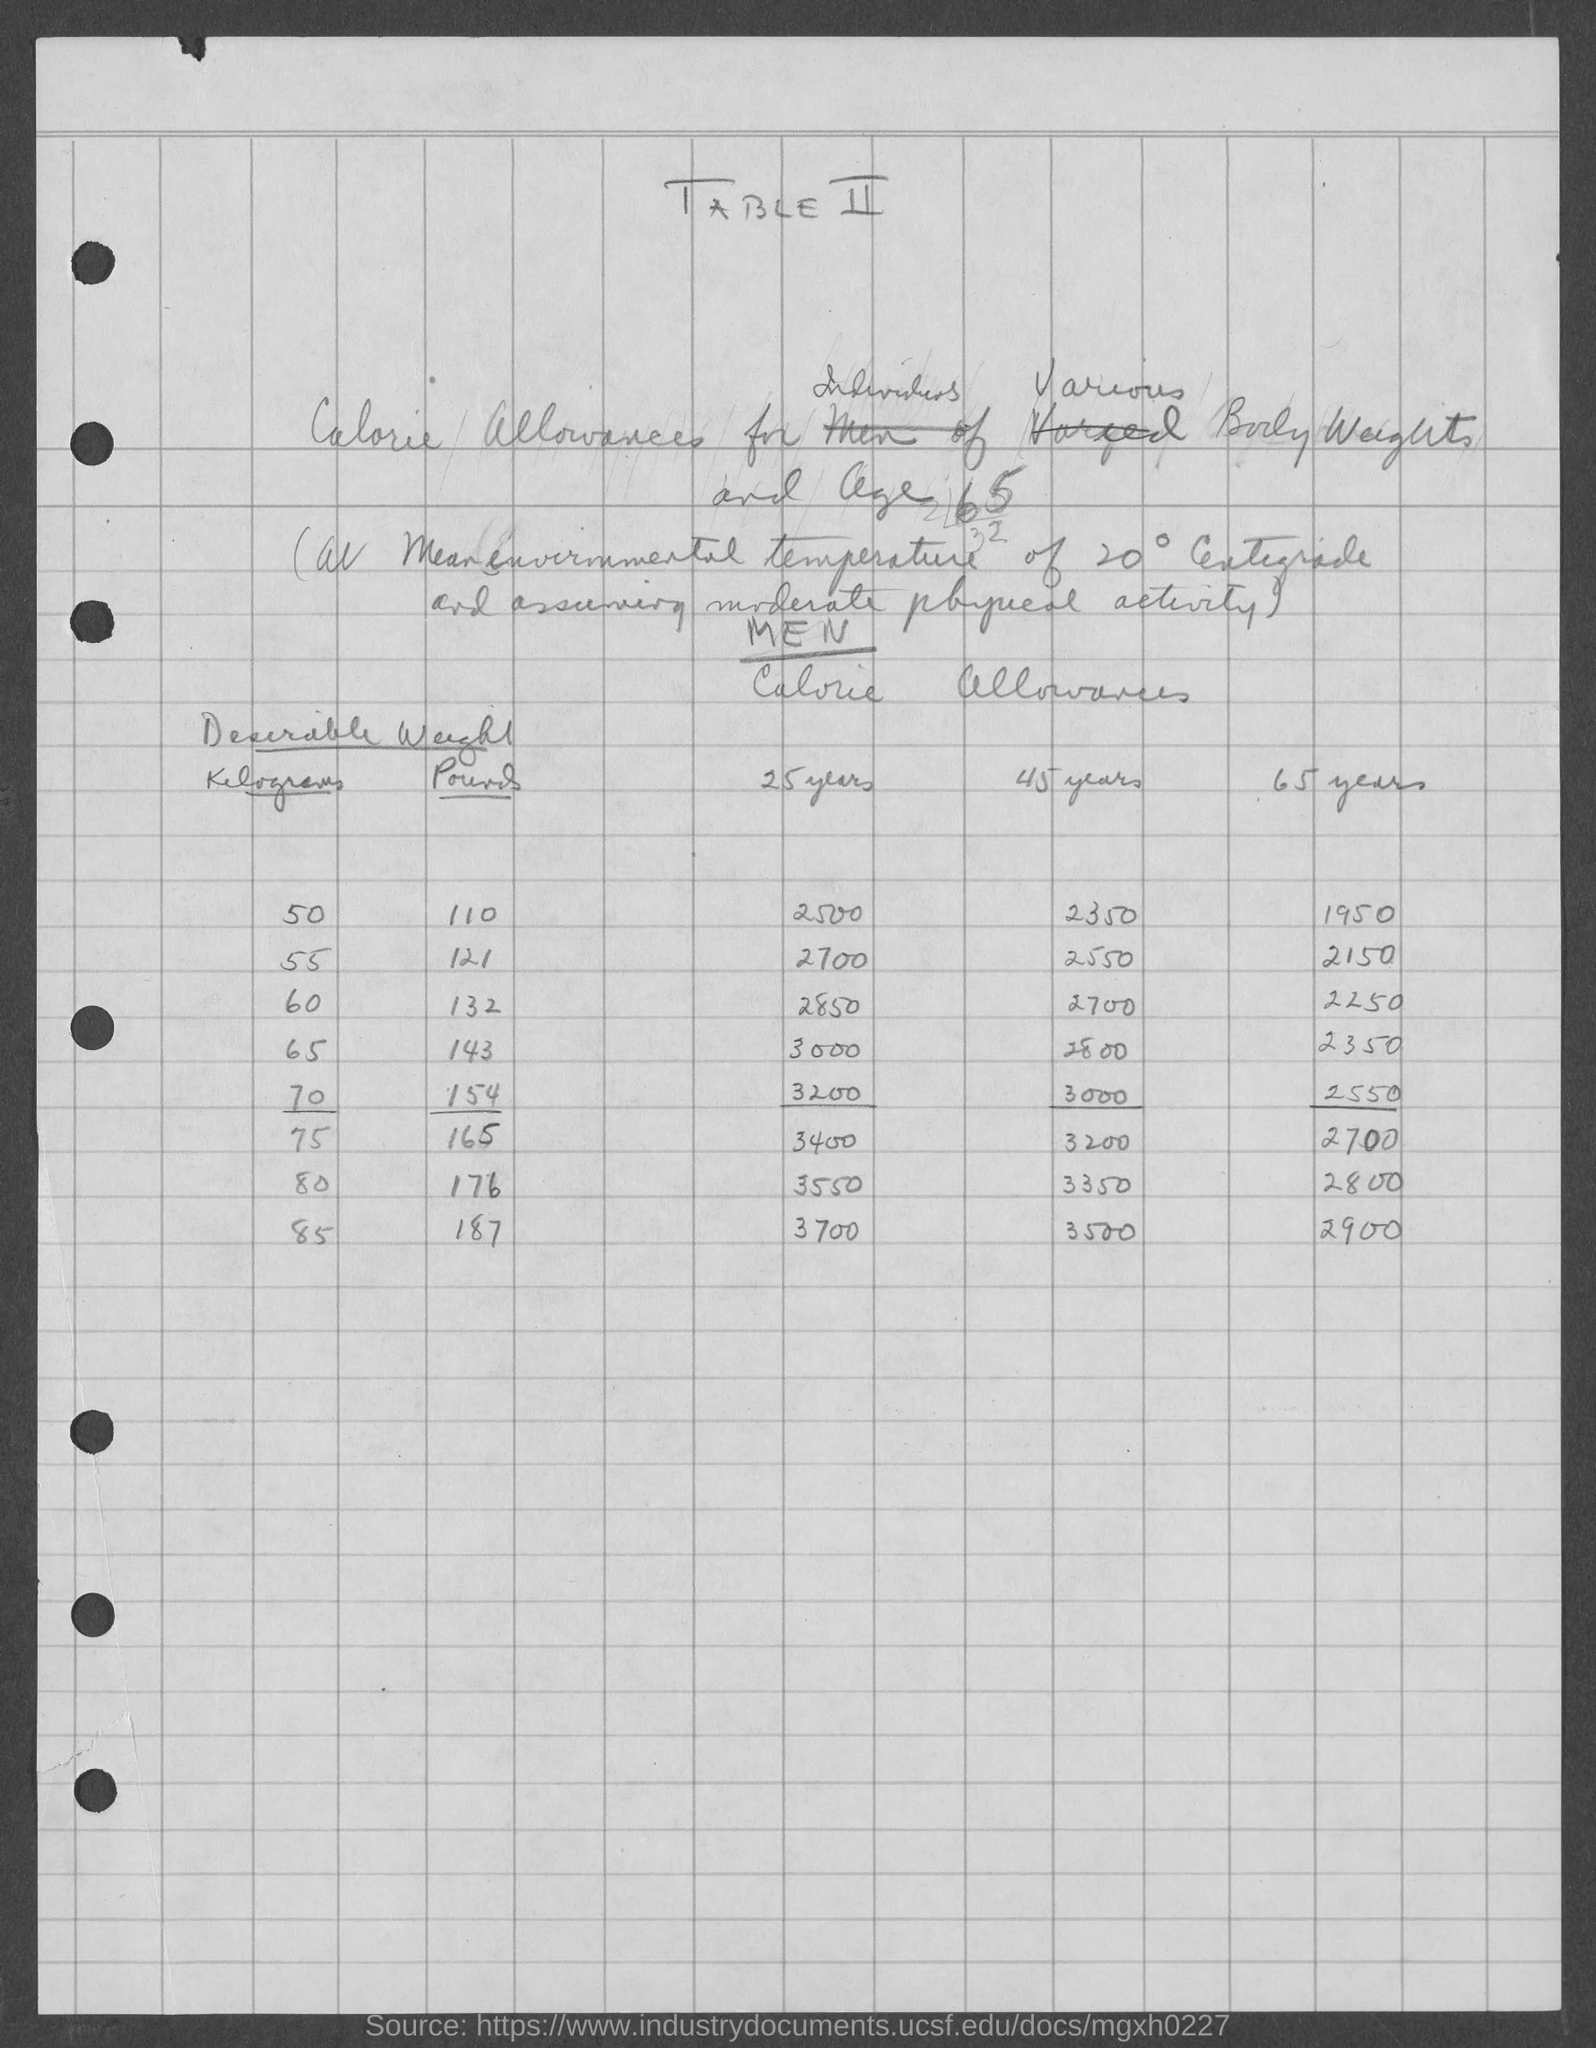What  is the heading of the document?
Your answer should be compact. TABLE II. Mention the heading of first column under "Desirable weight"?
Your answer should be very brief. KILOGRAM. Mention the heading of first age group mentioned under "Calorie allowances"?
Give a very brief answer. 25 YEARS. Provide the first "Calorie allowances" value given under 45 years?
Your answer should be compact. 2350. Provide the first "Calorie allowances" value given under 65 years?
Your answer should be compact. 1950. Provide the first "Calorie allowances" value given under 25 years?
Offer a very short reply. 2500. Mention the first "KILOGRAM" value mentioned under "Desirable Weight"?
Offer a terse response. 50. Mention the first "POUNDS" value mentioned under "Desirable Weight"?
Your response must be concise. 110. 